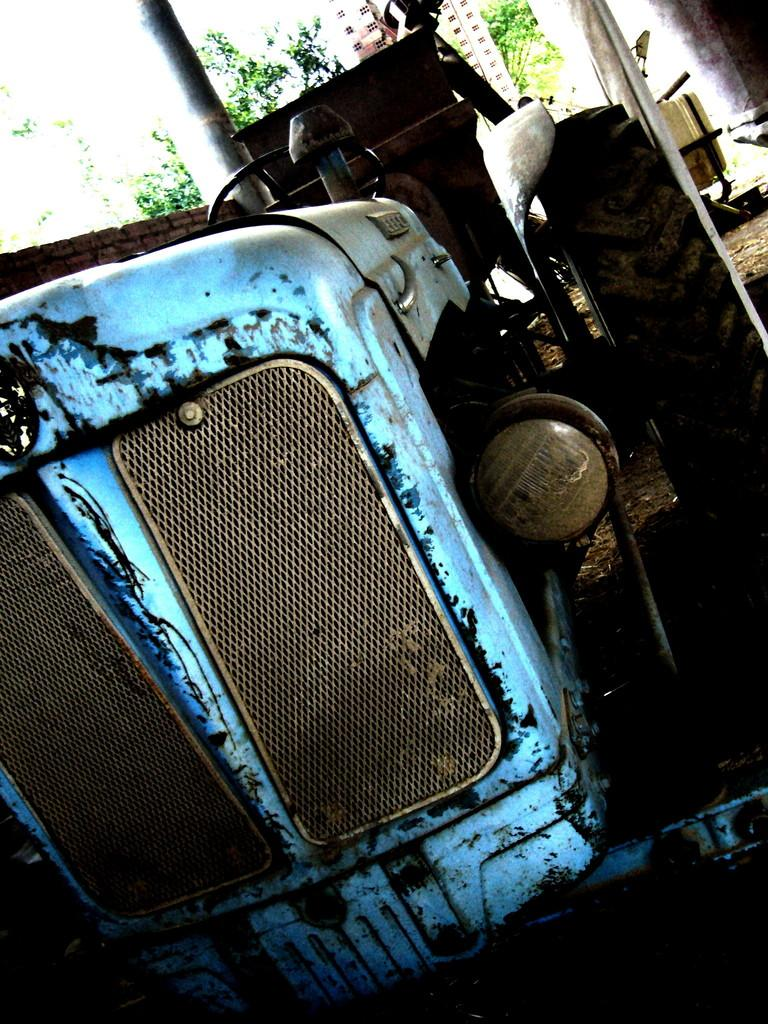What is the main subject of the image? The main subject of the image is a tractor on the ground. What can be seen in the background of the image? In the background of the image, there are trees, buildings, a wall, and an unspecified object. Can you describe the environment in which the tractor is located? The tractor is located in an environment with trees, buildings, and a wall in the background. What type of bedroom furniture can be seen in the image? There is no bedroom furniture present in the image; it features a tractor and background elements. How many pears are visible in the image? There are no pears present in the image. 